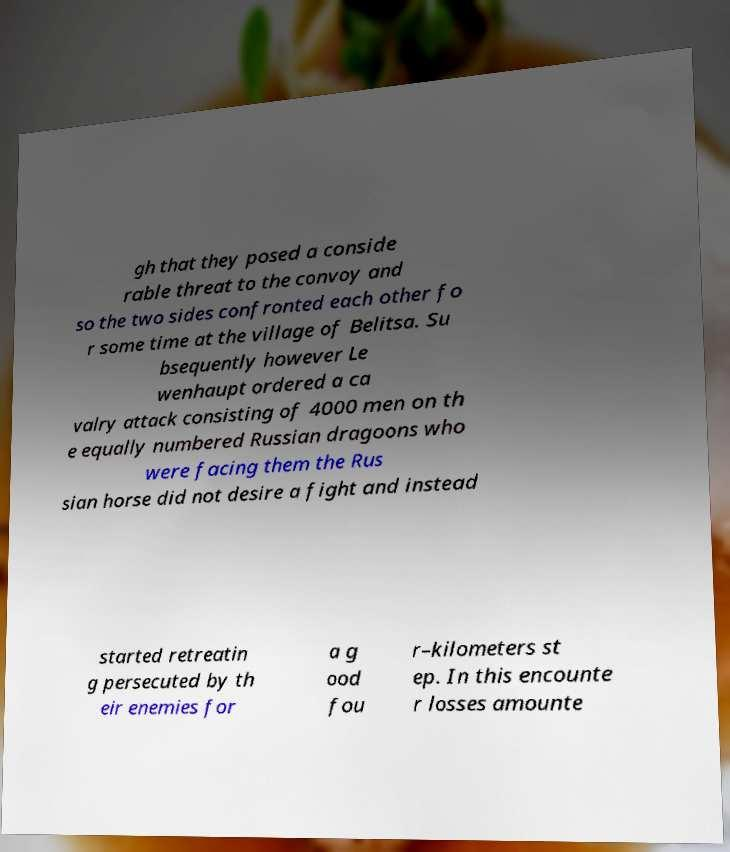I need the written content from this picture converted into text. Can you do that? gh that they posed a conside rable threat to the convoy and so the two sides confronted each other fo r some time at the village of Belitsa. Su bsequently however Le wenhaupt ordered a ca valry attack consisting of 4000 men on th e equally numbered Russian dragoons who were facing them the Rus sian horse did not desire a fight and instead started retreatin g persecuted by th eir enemies for a g ood fou r–kilometers st ep. In this encounte r losses amounte 